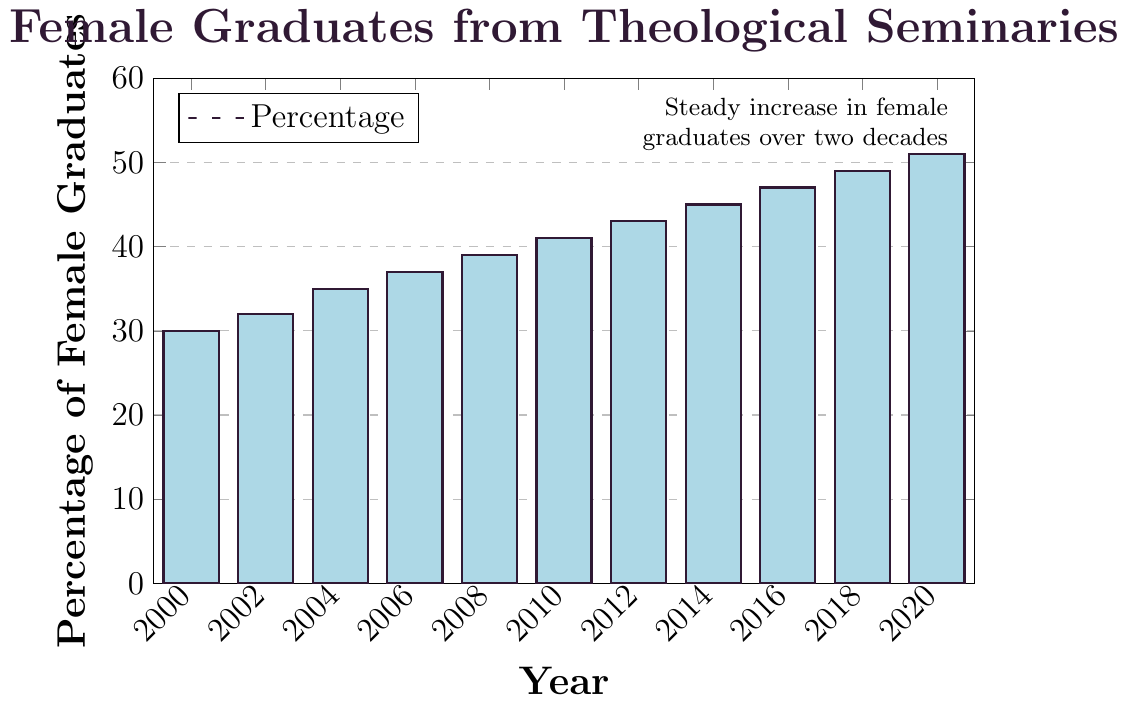What is the percentage of female graduates in 2008? Locate the bar corresponding to 2008 on the x-axis and find its height on the y-axis, which is 39.
Answer: 39% By how many percentage points did the percentage of female graduates increase from 2002 to 2006? Find the height of the bars for 2002 and 2006 on the y-axis, which are 32 and 37 respectively. Subtract 32 from 37 to find the increase.
Answer: 5 percentage points Which year had the highest percentage of female graduates? Identify the tallest bar in the chart, which corresponds to 2020.
Answer: 2020 What is the average percentage of female graduates between 2000 and 2010? Sum the percentages for the years 2000, 2002, 2004, 2006, 2008, 2010 (30 + 32 + 35 + 37 + 39 + 41 = 214) and divide by the number of years (6). The average is 214/6.
Answer: 35.67% Did the percentage of female graduates ever decrease over the two decades? Examine the trend of the bars from left to right, there is a consistent increase with no decrease.
Answer: No How many percentage points did the percentage of female graduates increase from 2000 to 2020? Subtract the percentage for 2000 (30) from the percentage for 2020 (51).
Answer: 21 percentage points Is the percentage of female graduates in 2016 greater than in 2010? Compare the height of the bars for 2016 (47%) and 2010 (41%).
Answer: Yes What is the difference in percentage of female graduates between 2006 and 2018? Find the heights of the bars for 2006 (37%) and 2018 (49%), then subtract 37 from 49.
Answer: 12 percentage points Which color are the bars in the chart? The bars are filled with a pastel blue color as described in the code and visual representation.
Answer: Pastel blue Is the percentage of female graduates in 2014 less than 50%? Check the height of the bar for 2014, which is 45%.
Answer: Yes 